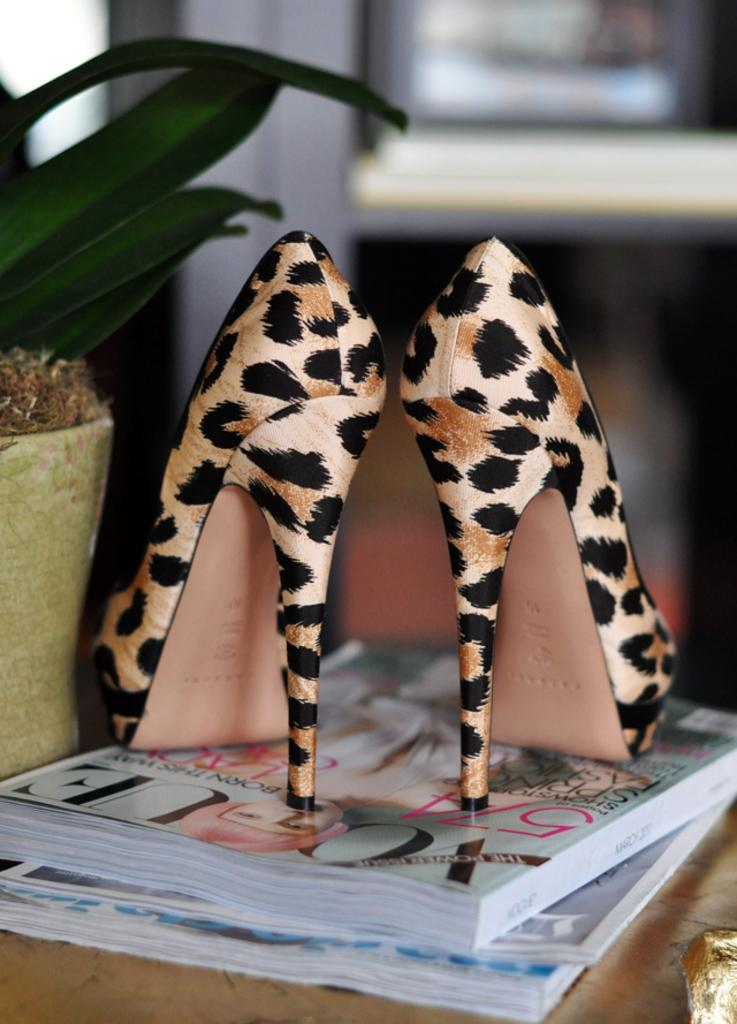What type of living organism can be seen in the image? There is a plant in the image. What is the unusual placement of the shoes in the image? There is a pair of heels on books in the image. What is the object on the table in the image? The object on the table is not specified in the facts, so we cannot answer this question definitively. How would you describe the background of the image? The background of the image is blurred. Can you hear the engine running in the image? There is no engine present in the image, so we cannot hear it running. What type of knot is tied around the plant in the image? There is no knot tied around the plant in the image. 